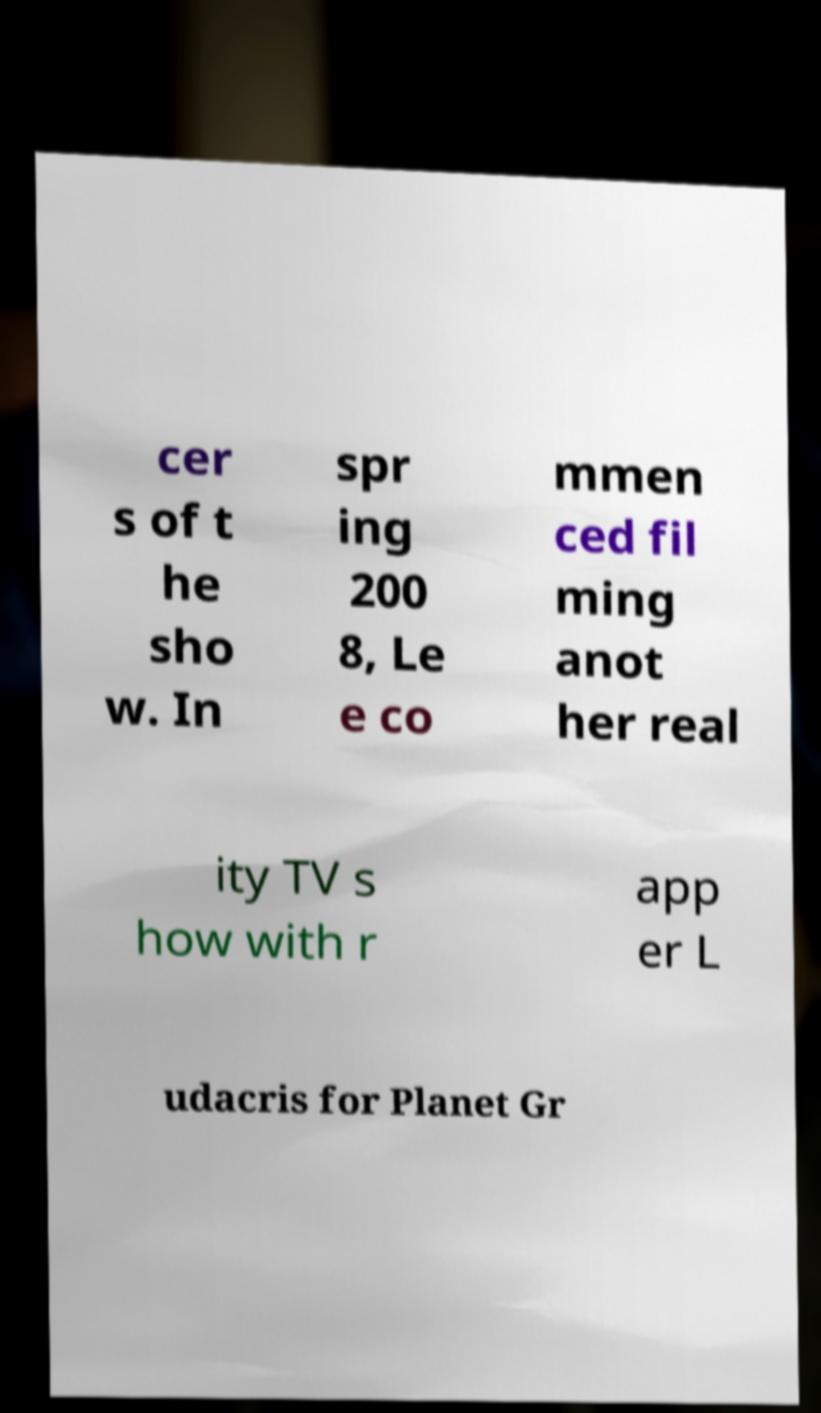Can you accurately transcribe the text from the provided image for me? cer s of t he sho w. In spr ing 200 8, Le e co mmen ced fil ming anot her real ity TV s how with r app er L udacris for Planet Gr 